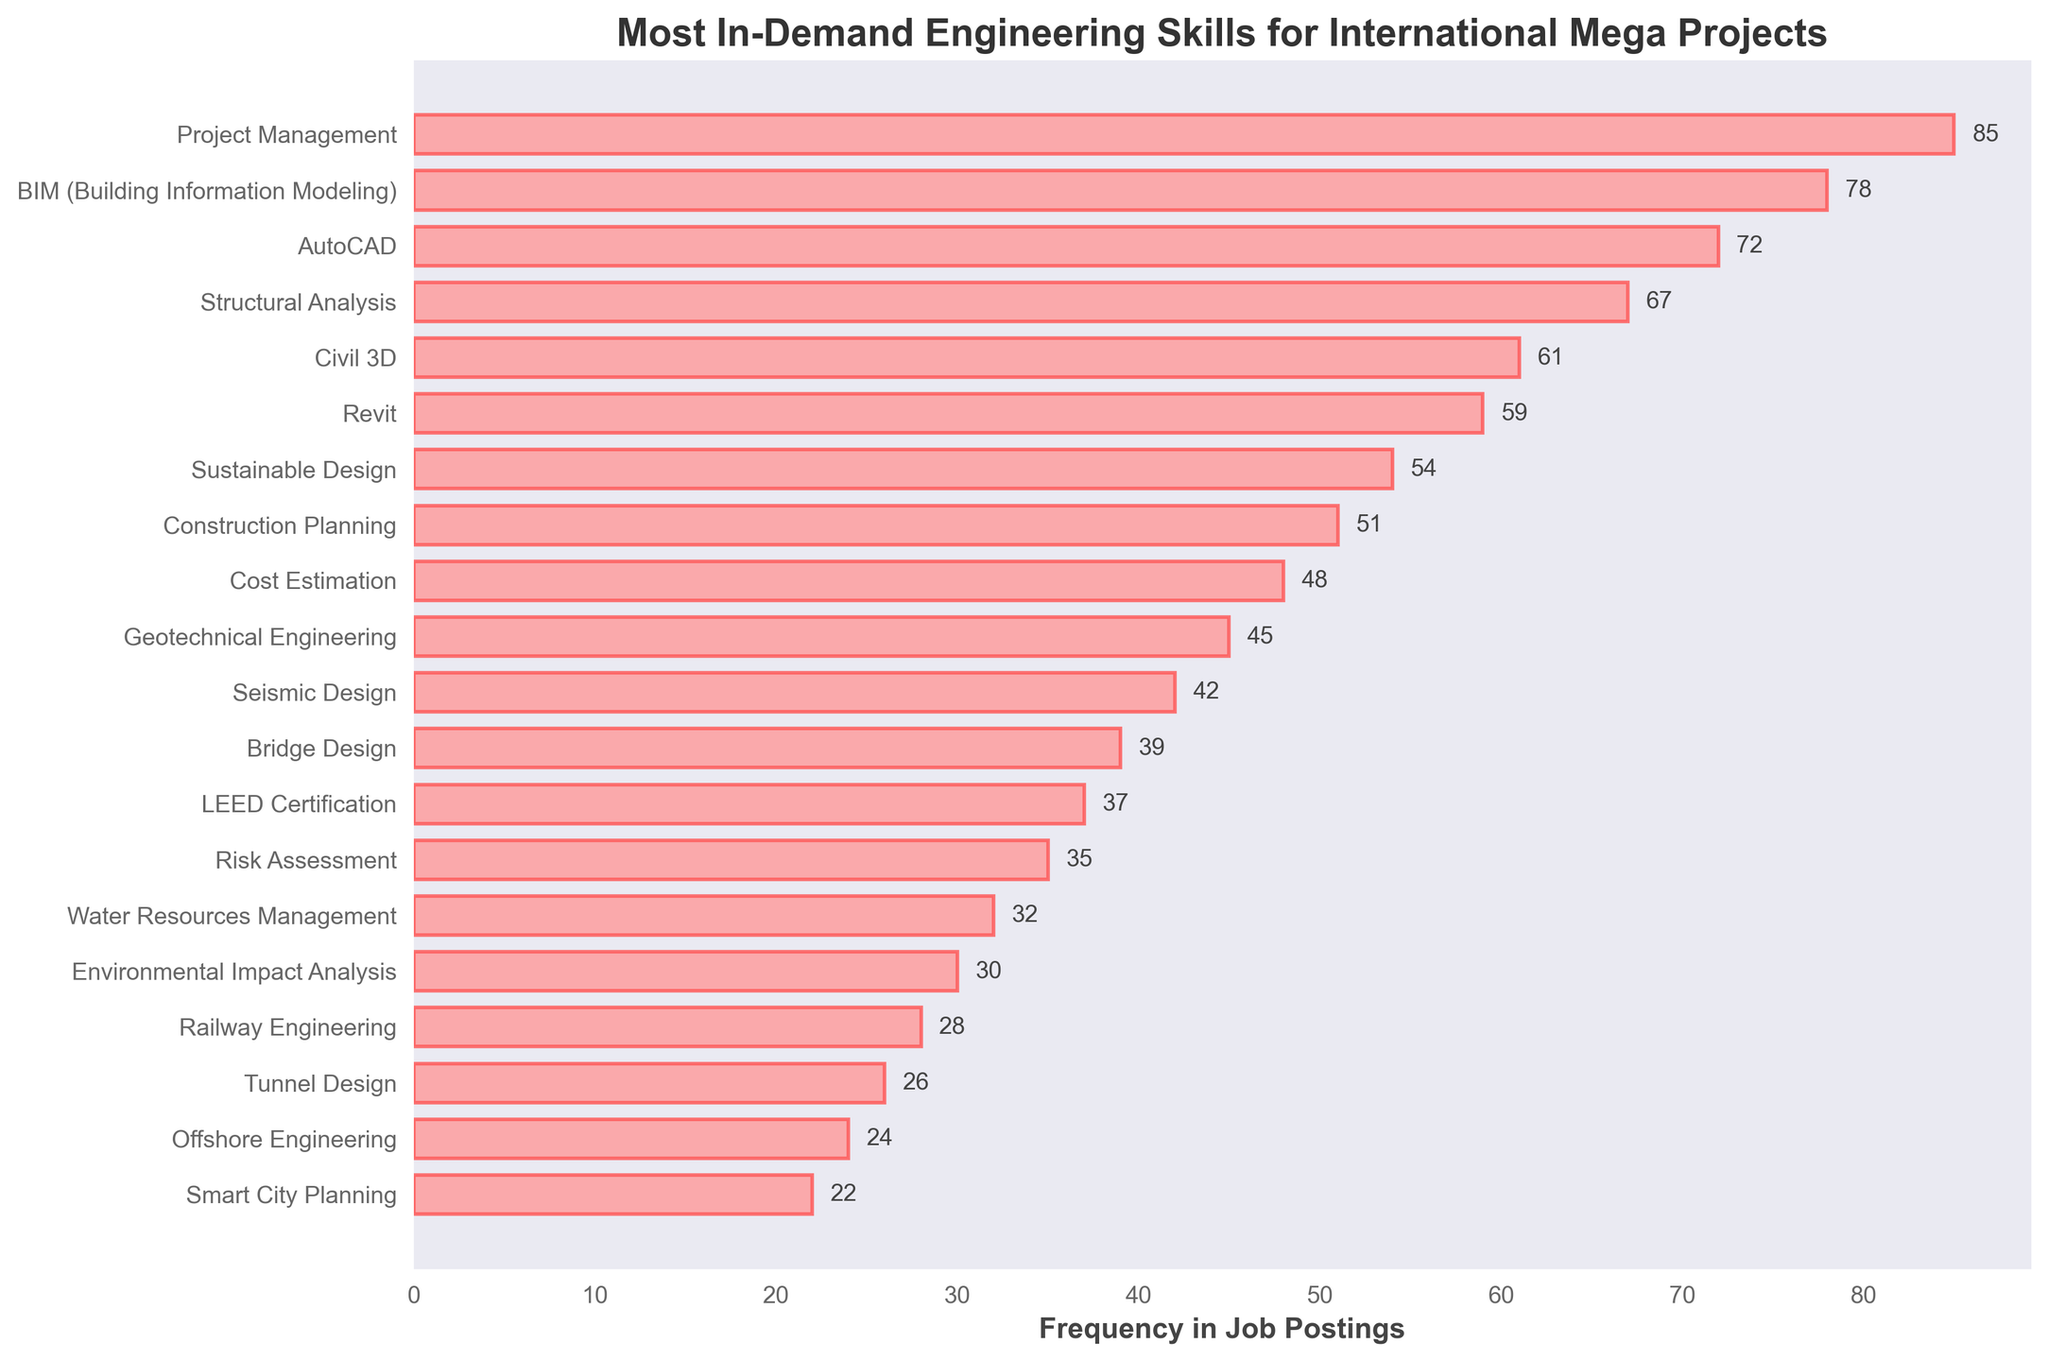Which skill has the highest frequency in job postings? The skill with the highest bar length indicates the highest frequency. In the figure, "Project Management" has the longest bar.
Answer: Project Management Which skill appears less frequently in job postings: Revit or Civil 3D? By comparing the lengths of the bars, we see that "Revit" appears less frequently (59) than "Civil 3D" (61).
Answer: Revit What is the combined frequency of AutoCAD and Structural Analysis? Adding the frequencies from "AutoCAD" (72) and "Structural Analysis" (67) gives \(72 + 67 = 139\).
Answer: 139 Which skill has the shortest bar in the figure? The shortest bar represents the skill with the lowest frequency. Here, "Smart City Planning" has the shortest bar.
Answer: Smart City Planning How many skills have a frequency above 50? Count the number of bars with lengths representing frequencies greater than 50. In this case, there are 8 skills.
Answer: 8 What is the average frequency of Seismic Design and Bridge Design? Adding the frequencies of "Seismic Design" (42) and "Bridge Design" (39) and then dividing by 2 gives \(\frac{42 + 39}{2} = 40.5\).
Answer: 40.5 Which skills are ranked equally high in frequency in job postings? Look for bars of equal length. None of the skills share an exact frequency in this figure.
Answer: None Which skill is more frequently mentioned in job postings: Geotechnical Engineering or Water Resources Management? Compare the bar lengths; "Geotechnical Engineering" (45) is more frequently mentioned than "Water Resources Management" (32).
Answer: Geotechnical Engineering What is the frequency difference between Sustainable Design and Cost Estimation? Subtract the frequency of "Cost Estimation" (48) from "Sustainable Design" (54) giving \(54 - 48 = 6\).
Answer: 6 